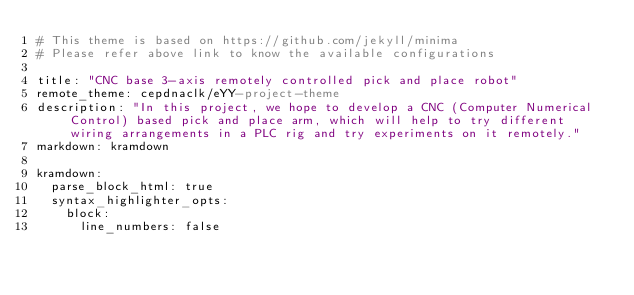<code> <loc_0><loc_0><loc_500><loc_500><_YAML_># This theme is based on https://github.com/jekyll/minima
# Please refer above link to know the available configurations

title: "CNC base 3-axis remotely controlled pick and place robot"
remote_theme: cepdnaclk/eYY-project-theme
description: "In this project, we hope to develop a CNC (Computer Numerical Control) based pick and place arm, which will help to try different wiring arrangements in a PLC rig and try experiments on it remotely."
markdown: kramdown

kramdown:
  parse_block_html: true
  syntax_highlighter_opts:
    block:
      line_numbers: false
</code> 